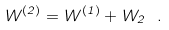Convert formula to latex. <formula><loc_0><loc_0><loc_500><loc_500>W ^ { ( 2 ) } = W ^ { ( 1 ) } + W _ { 2 } \ .</formula> 